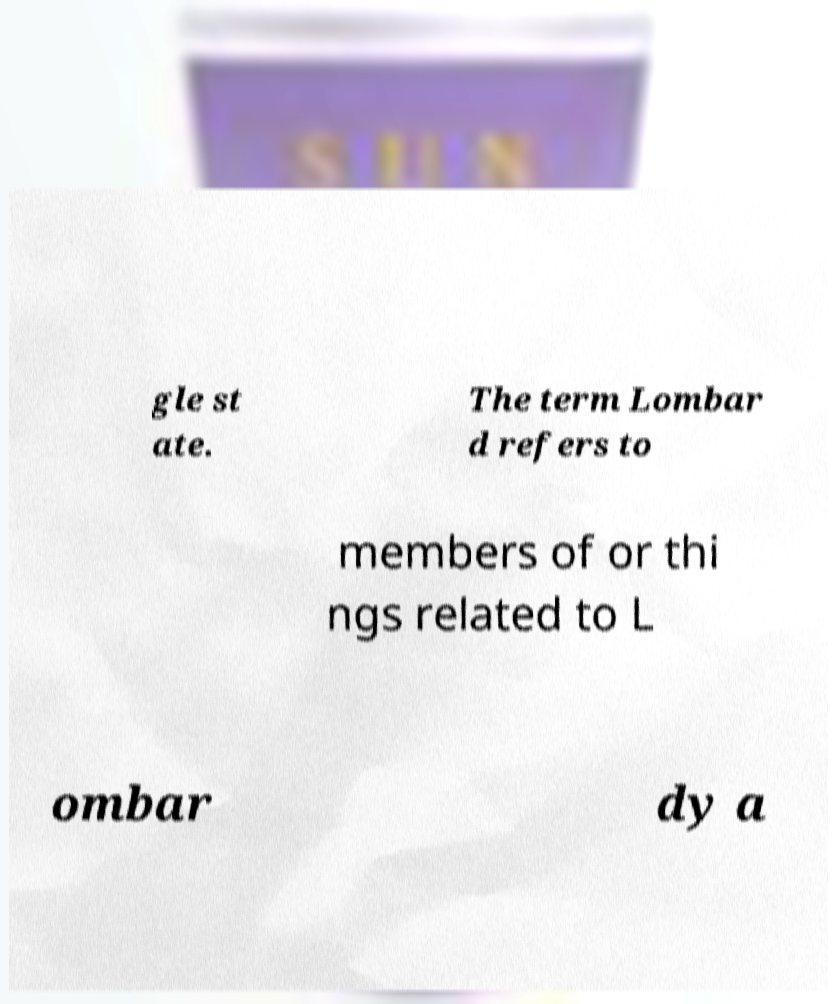I need the written content from this picture converted into text. Can you do that? gle st ate. The term Lombar d refers to members of or thi ngs related to L ombar dy a 